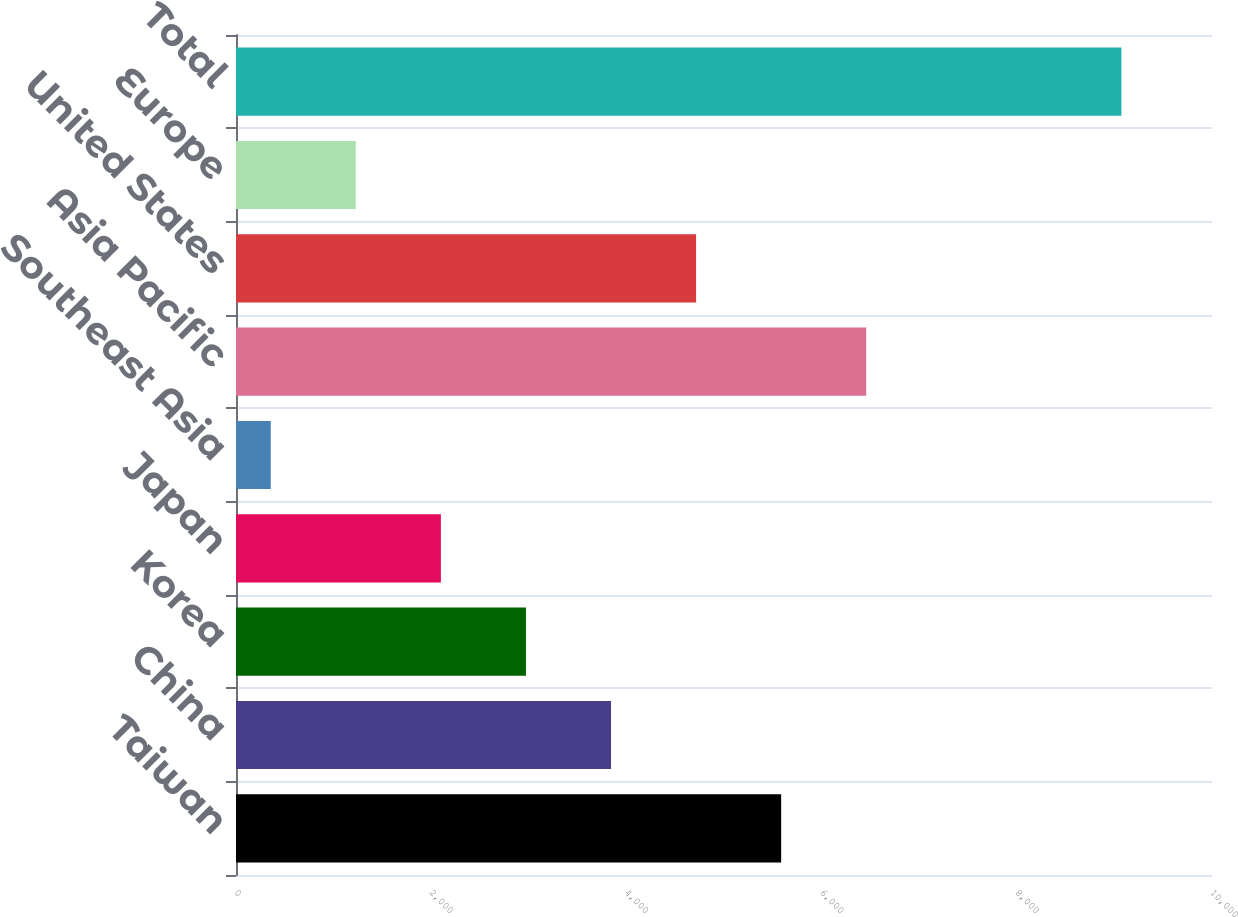<chart> <loc_0><loc_0><loc_500><loc_500><bar_chart><fcel>Taiwan<fcel>China<fcel>Korea<fcel>Japan<fcel>Southeast Asia<fcel>Asia Pacific<fcel>United States<fcel>Europe<fcel>Total<nl><fcel>5585.6<fcel>3842.4<fcel>2970.8<fcel>2099.2<fcel>356<fcel>6457.2<fcel>4714<fcel>1227.6<fcel>9072<nl></chart> 